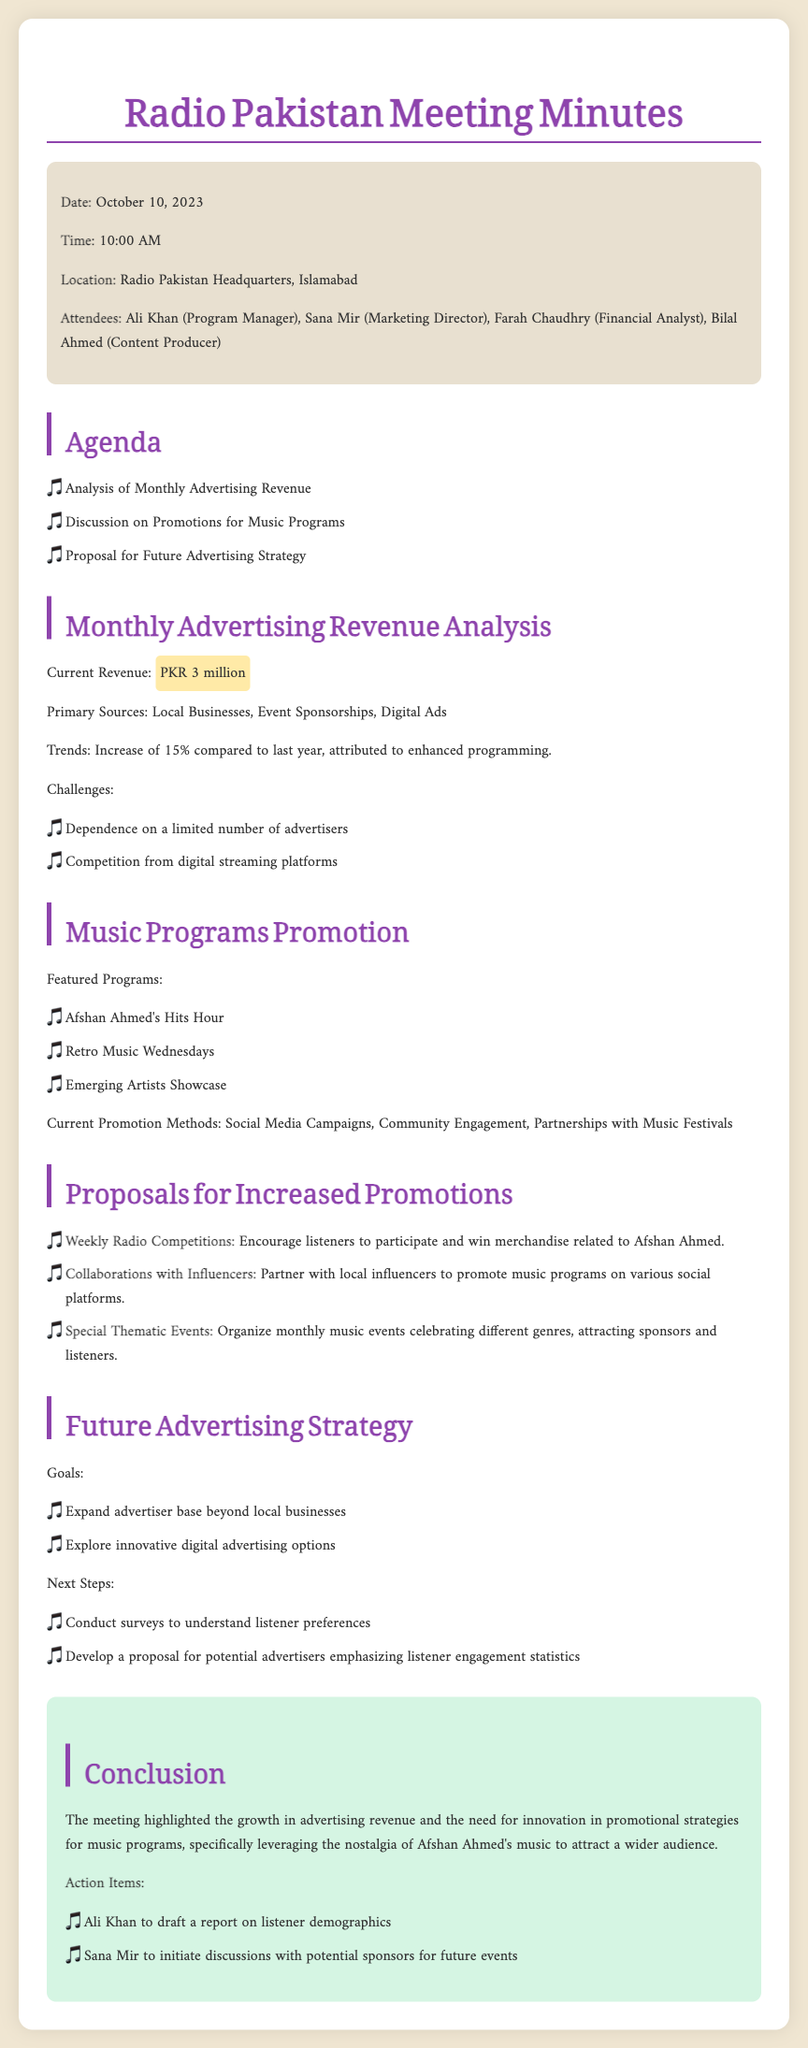what is the current revenue? The meeting minutes state the current revenue as PKR 3 million.
Answer: PKR 3 million who is the Marketing Director? The document lists Sana Mir as the Marketing Director.
Answer: Sana Mir what is the percentage increase in revenue compared to last year? The minutes mention a 15% increase in revenue compared to last year.
Answer: 15% name one of the featured music programs. The document lists "Afshan Ahmed's Hits Hour" as one of the featured music programs.
Answer: Afshan Ahmed's Hits Hour what is one challenge mentioned regarding advertising? The minutes mention dependence on a limited number of advertisers as a challenge.
Answer: Dependence on a limited number of advertisers who is responsible for drafting a report on listener demographics? The document assigns the task of drafting the report to Ali Khan.
Answer: Ali Khan what is one proposed method for increased promotions? The document proposes weekly radio competitions as a method for increased promotions.
Answer: Weekly Radio Competitions what is the date of the meeting? The document states that the meeting took place on October 10, 2023.
Answer: October 10, 2023 what are the next steps mentioned in the future advertising strategy? The document lists conducting surveys to understand listener preferences as a next step.
Answer: Conduct surveys to understand listener preferences 